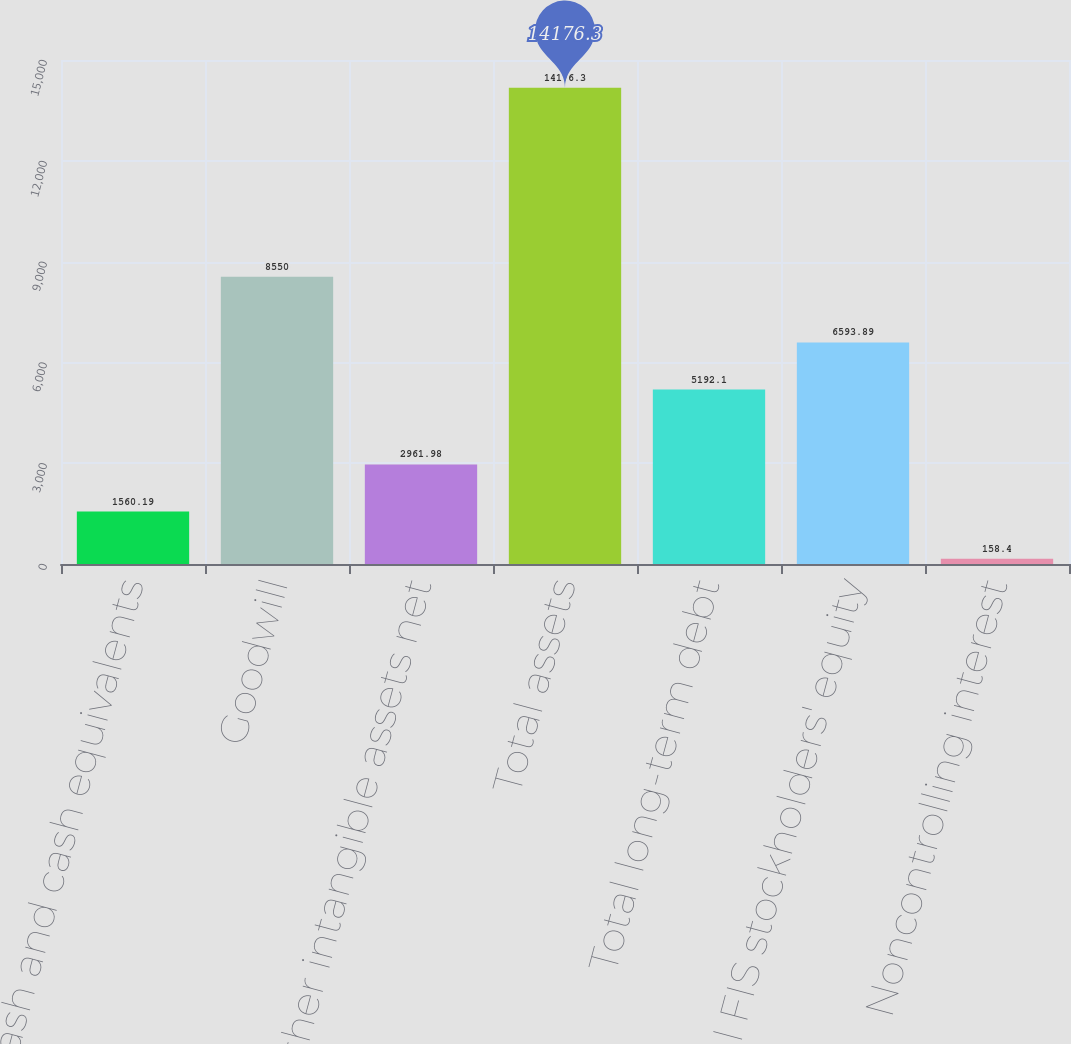Convert chart. <chart><loc_0><loc_0><loc_500><loc_500><bar_chart><fcel>Cash and cash equivalents<fcel>Goodwill<fcel>Other intangible assets net<fcel>Total assets<fcel>Total long-term debt<fcel>Total FIS stockholders' equity<fcel>Noncontrolling interest<nl><fcel>1560.19<fcel>8550<fcel>2961.98<fcel>14176.3<fcel>5192.1<fcel>6593.89<fcel>158.4<nl></chart> 